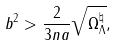<formula> <loc_0><loc_0><loc_500><loc_500>b ^ { 2 } > \frac { 2 } { 3 n a } \sqrt { \Omega _ { \Lambda } ^ { \natural } } ,</formula> 